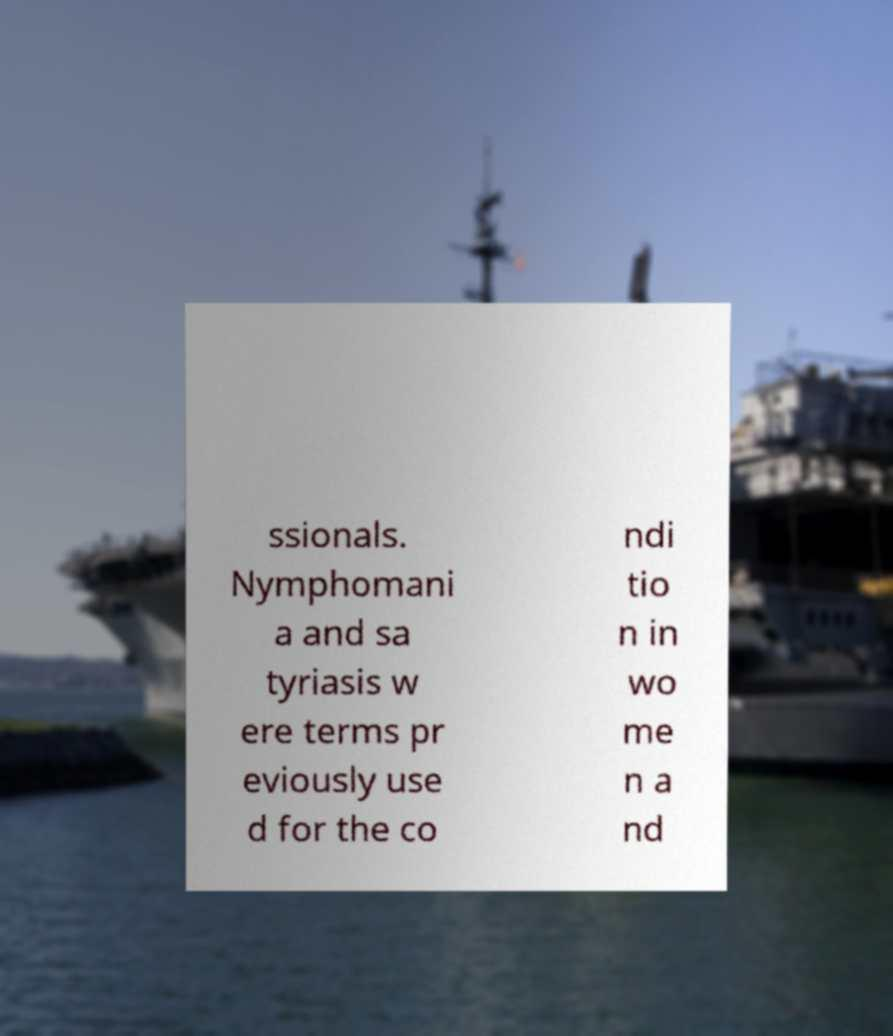There's text embedded in this image that I need extracted. Can you transcribe it verbatim? ssionals. Nymphomani a and sa tyriasis w ere terms pr eviously use d for the co ndi tio n in wo me n a nd 